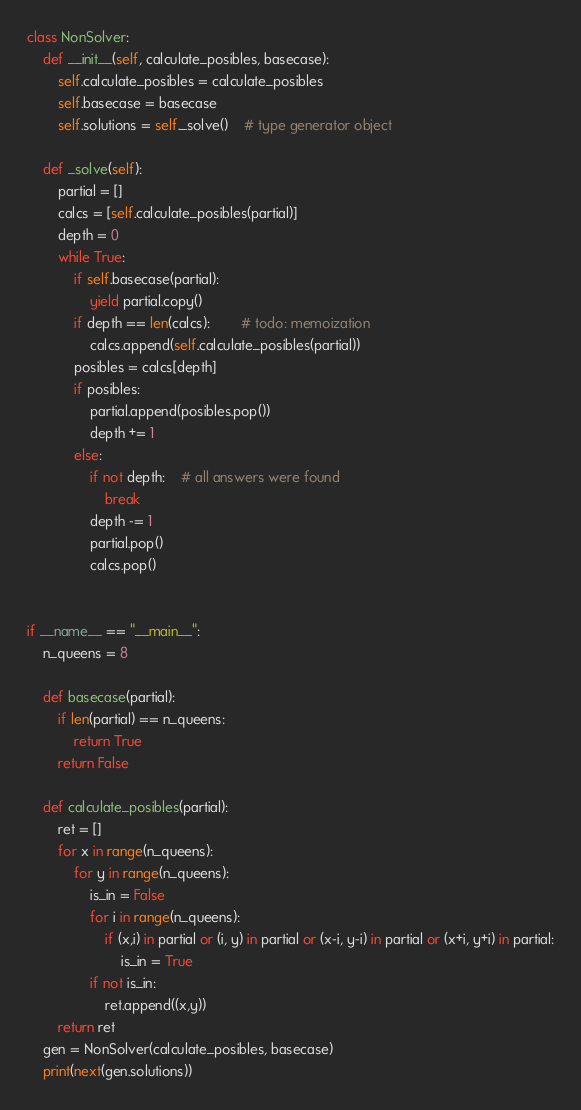<code> <loc_0><loc_0><loc_500><loc_500><_Python_>class NonSolver:
	def __init__(self, calculate_posibles, basecase):
		self.calculate_posibles = calculate_posibles
		self.basecase = basecase
		self.solutions = self._solve()	# type generator object

	def _solve(self):
		partial = []
		calcs = [self.calculate_posibles(partial)]
		depth = 0
		while True:
			if self.basecase(partial):
				yield partial.copy()
			if depth == len(calcs):		# todo: memoization
				calcs.append(self.calculate_posibles(partial))
			posibles = calcs[depth]
			if posibles:
				partial.append(posibles.pop())
				depth += 1
			else:
				if not depth:	# all answers were found
					break
				depth -= 1
				partial.pop()
				calcs.pop()


if __name__ == "__main__":
	n_queens = 8

	def basecase(partial):
		if len(partial) == n_queens:
			return True
		return False

	def calculate_posibles(partial):
		ret = []
		for x in range(n_queens):
			for y in range(n_queens):
				is_in = False
				for i in range(n_queens):
					if (x,i) in partial or (i, y) in partial or (x-i, y-i) in partial or (x+i, y+i) in partial:
						is_in = True
				if not is_in: 
					ret.append((x,y))
		return ret
	gen = NonSolver(calculate_posibles, basecase)
	print(next(gen.solutions))
</code> 